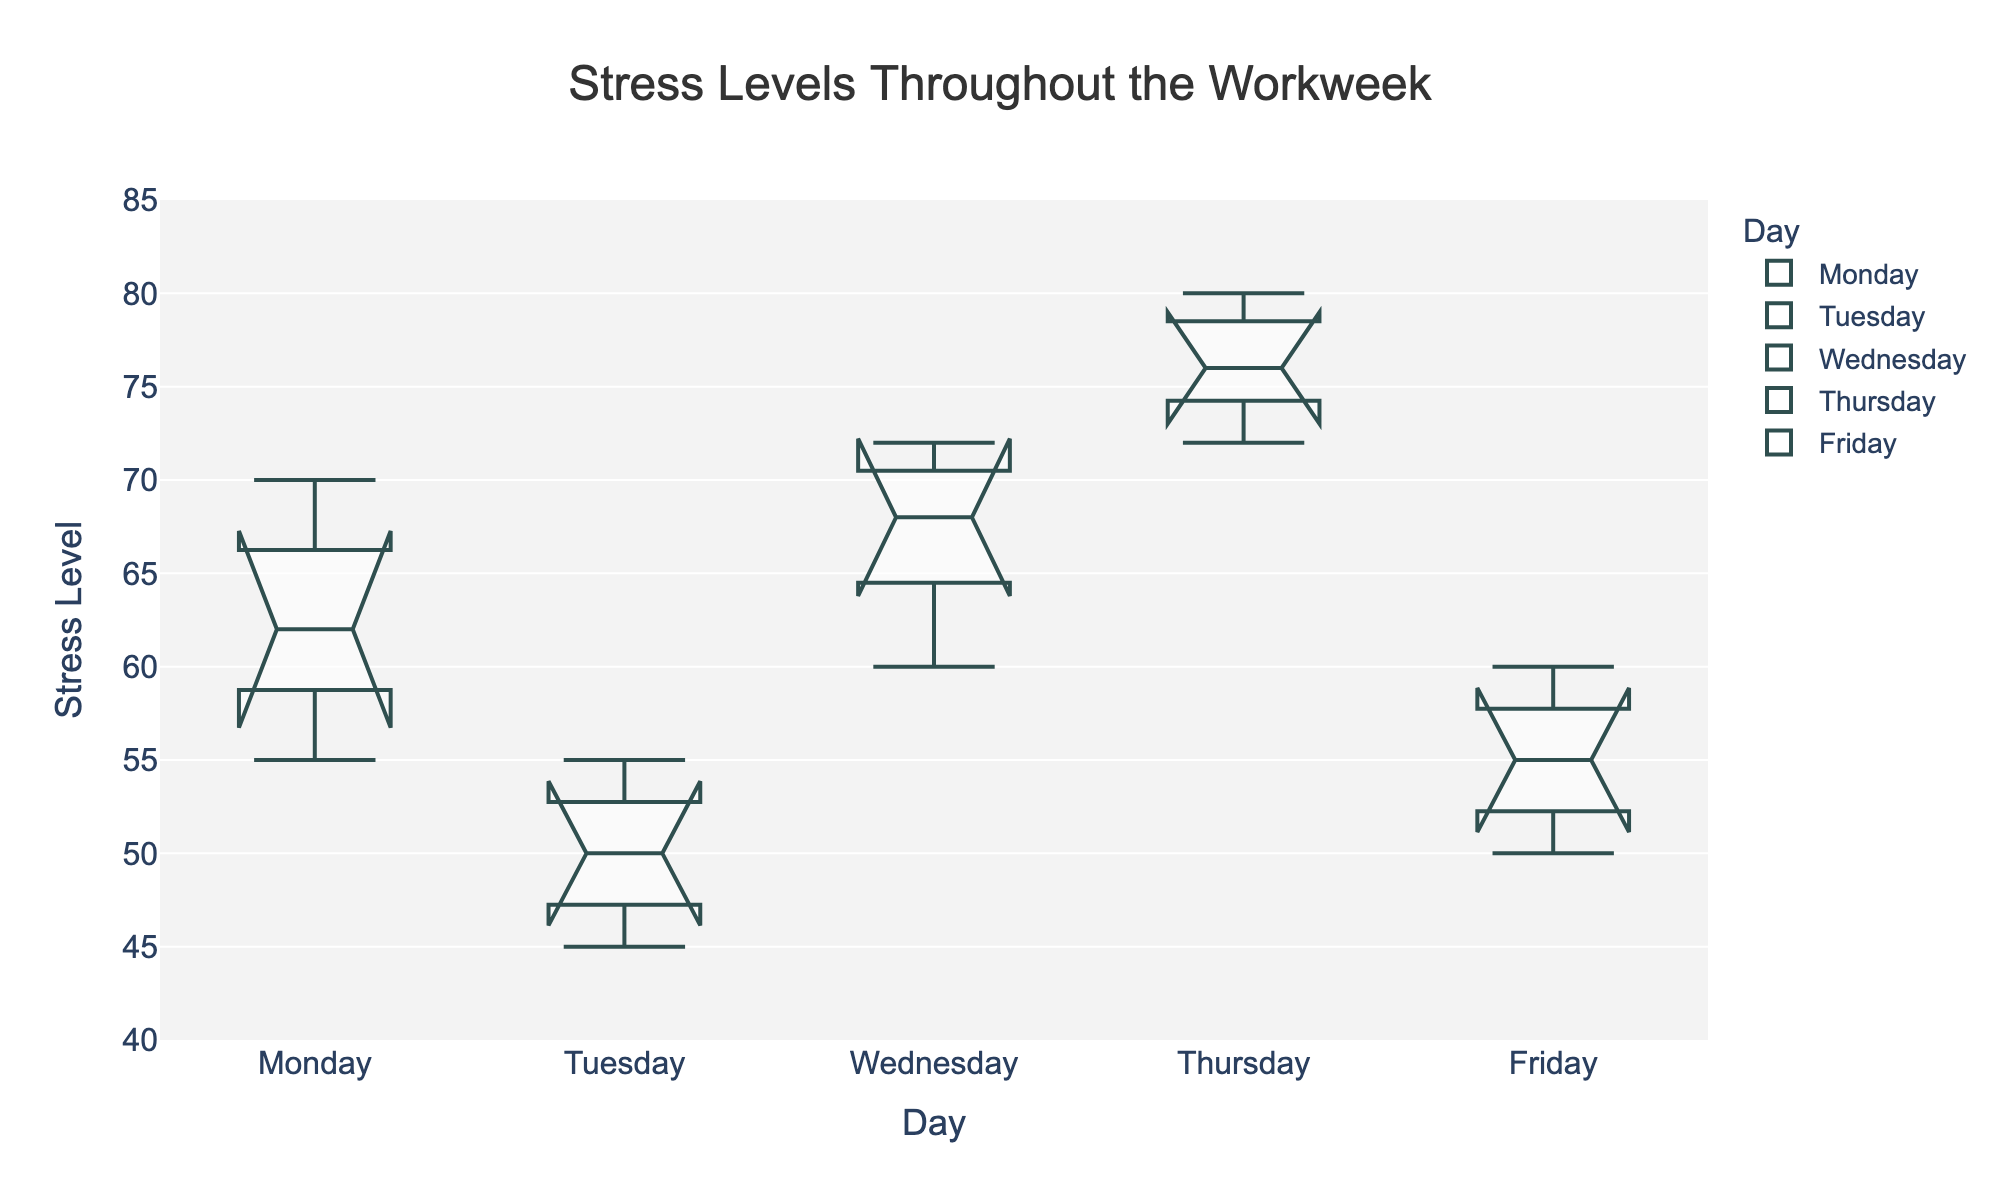What's the title of the plot? The title of the plot is usually printed at the top center of the plot. In this case, it's indicated that the title is "Stress Levels Throughout the Workweek".
Answer: Stress Levels Throughout the Workweek What are the days of the week represented in the plot? Look at the x-axis. The plot shows data segmented by days of the week from Monday to Friday.
Answer: Monday, Tuesday, Wednesday, Thursday, Friday What is the median stress level on Thursday? In a notched box plot, the median is represented by the line inside the box. For Thursday, visualize the location of the line within the Thursday box.
Answer: 76 Which day has the lowest median stress level? Compare the lines representing the median in the boxes for each day. The lowest one is the one to look for.
Answer: Tuesday On which day is the spread of stress levels the widest? The spread of the data is indicated by the length of the boxes and whiskers. Look for the day with the longest box-and-whisker combination.
Answer: Thursday What is the approximate interquartile range (IQR) for Wednesday? The IQR can be calculated by subtracting the value at the lower quartile (bottom of the box) from the value at the upper quartile (top of the box).
Answer: ~8 Which day shows the highest variation in stress levels? Variation in a notched box plot can be indicated by the total length of the box and whiskers. Identify which day's box-and-whisker plot covers the widest range.
Answer: Thursday Is there any overlap in the notches between Monday and Tuesday? Look at the notches within the boxes for both Monday and Tuesday to see if they overlap. In a notched box plot, the notches represent the 95% confidence interval for the median.
Answer: No How does the median stress level on Friday compare to that on Monday? Compare the lines representing the medians for both Monday and Friday. Assess which is higher.
Answer: Monday's median is higher than Friday's Which day has the narrowest confidence interval for the median stress level? The width of the notches represents the confidence interval. Identify the day with the smallest notch width.
Answer: Tuesday 